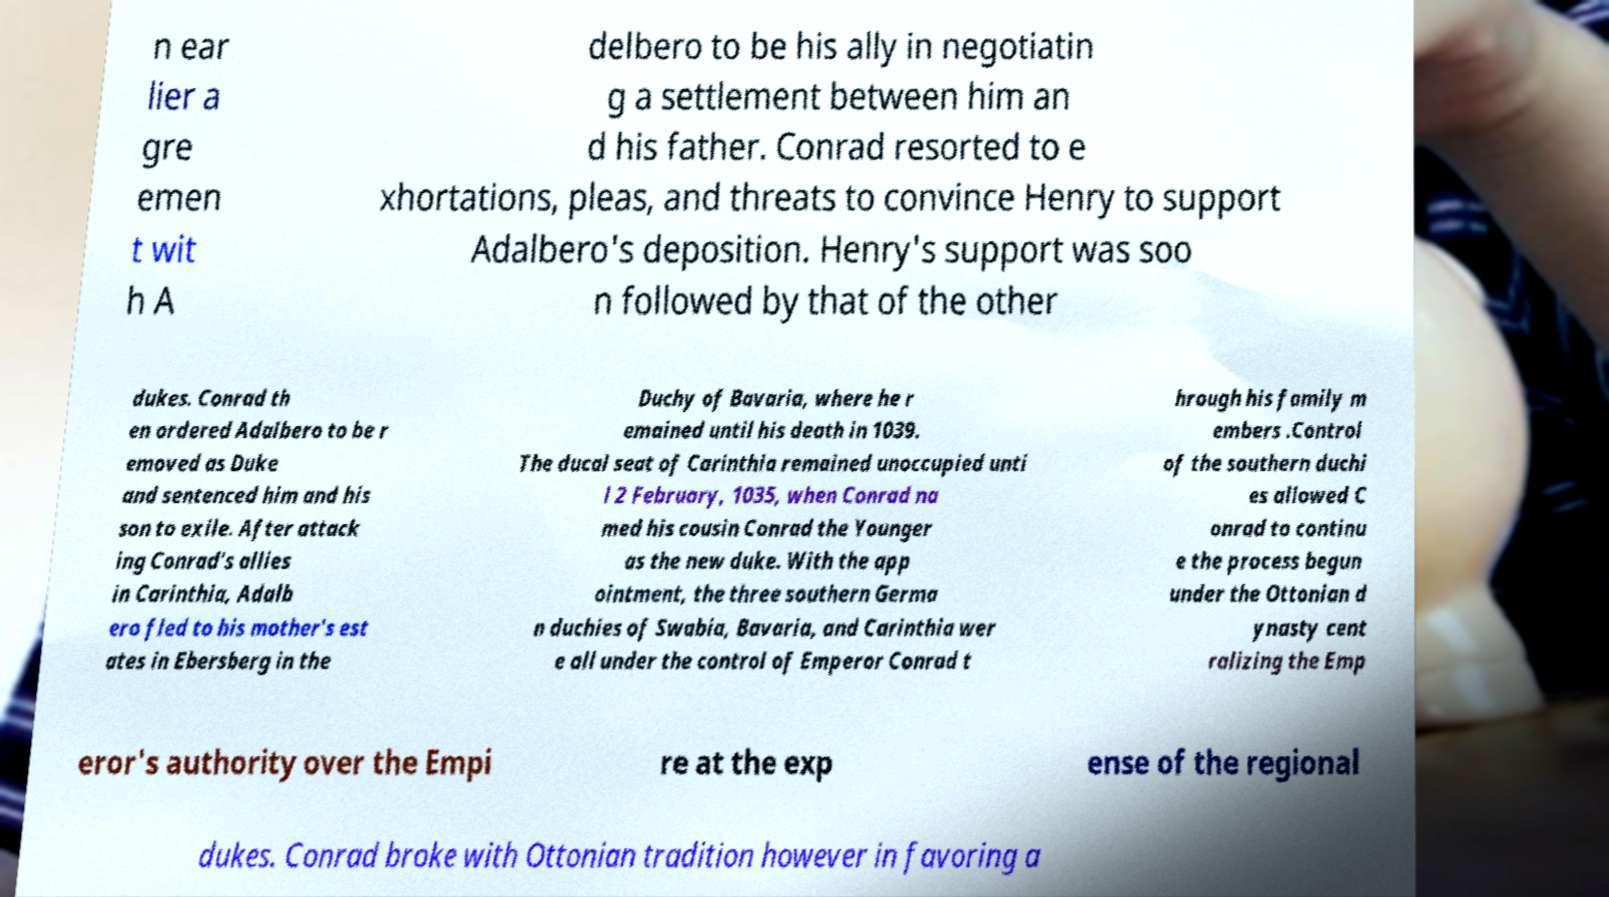Can you read and provide the text displayed in the image?This photo seems to have some interesting text. Can you extract and type it out for me? n ear lier a gre emen t wit h A delbero to be his ally in negotiatin g a settlement between him an d his father. Conrad resorted to e xhortations, pleas, and threats to convince Henry to support Adalbero's deposition. Henry's support was soo n followed by that of the other dukes. Conrad th en ordered Adalbero to be r emoved as Duke and sentenced him and his son to exile. After attack ing Conrad's allies in Carinthia, Adalb ero fled to his mother's est ates in Ebersberg in the Duchy of Bavaria, where he r emained until his death in 1039. The ducal seat of Carinthia remained unoccupied unti l 2 February, 1035, when Conrad na med his cousin Conrad the Younger as the new duke. With the app ointment, the three southern Germa n duchies of Swabia, Bavaria, and Carinthia wer e all under the control of Emperor Conrad t hrough his family m embers .Control of the southern duchi es allowed C onrad to continu e the process begun under the Ottonian d ynasty cent ralizing the Emp eror's authority over the Empi re at the exp ense of the regional dukes. Conrad broke with Ottonian tradition however in favoring a 